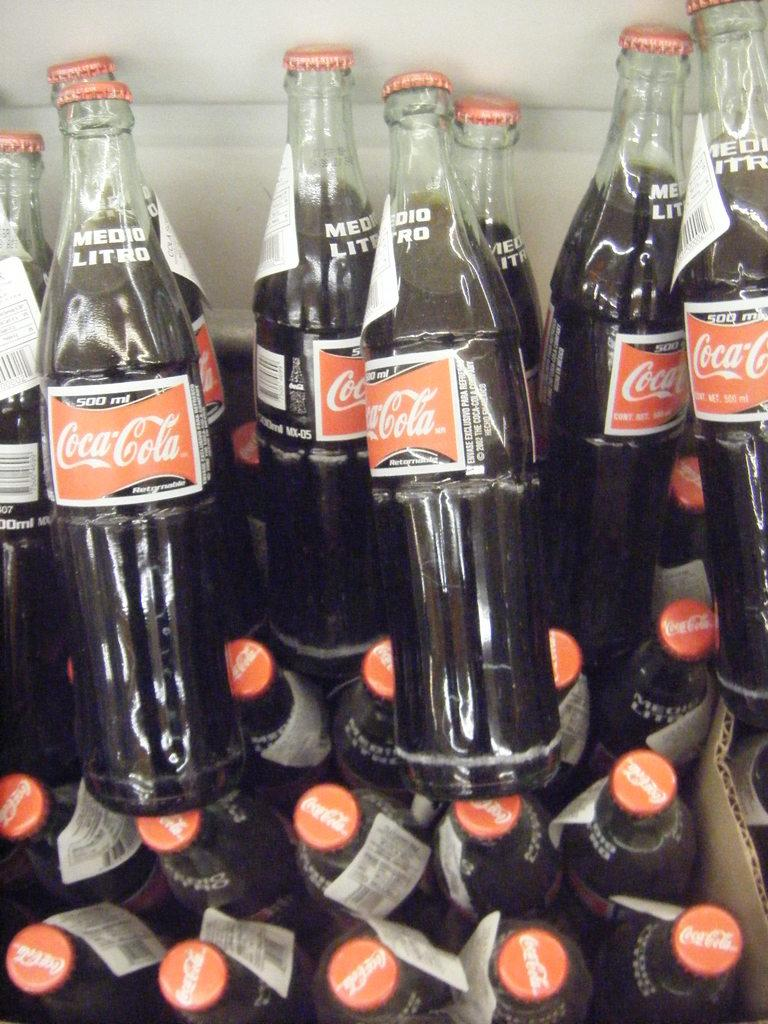<image>
Give a short and clear explanation of the subsequent image. several bottles of Coca Cola are stacked on top of each other 